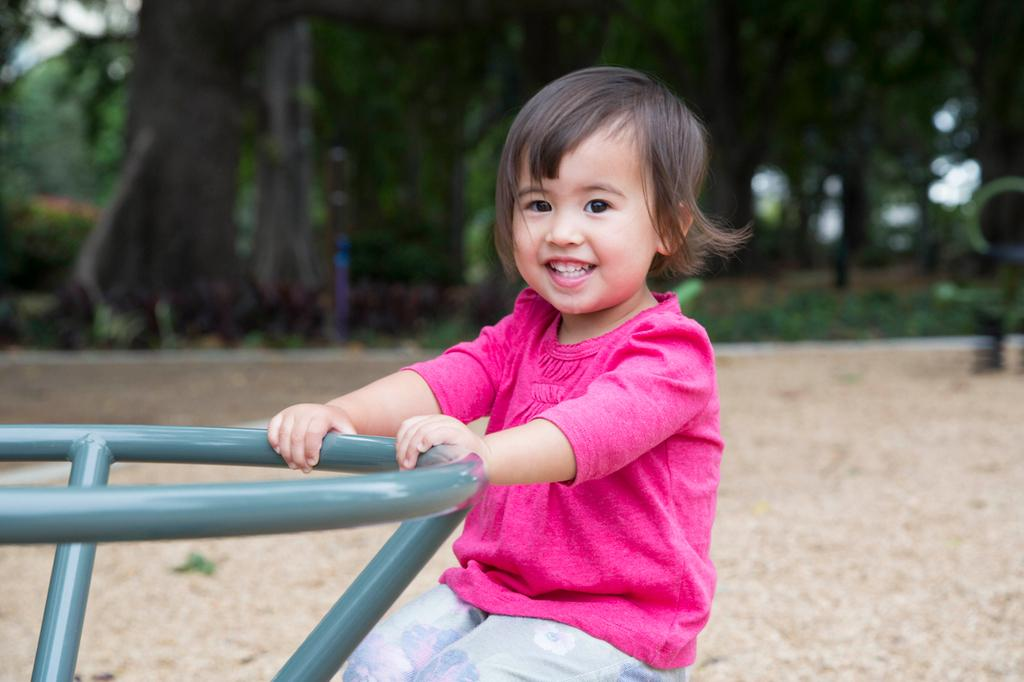What is the main subject of the image? The main subject of the image is a kid. What is the kid doing in the image? The kid is sitting and smiling. What is the kid holding in the image? The kid is holding an object. What can be seen in the background of the image? There is land and trees visible in the background of the image. What type of thrill can be seen in the kid's eyes in the image? There is no indication of a thrill or any specific emotion in the kid's eyes in the image. What advice is the kid giving to the trees in the background? There is no interaction or communication between the kid and the trees in the image, so it's not possible to determine any advice being given. 